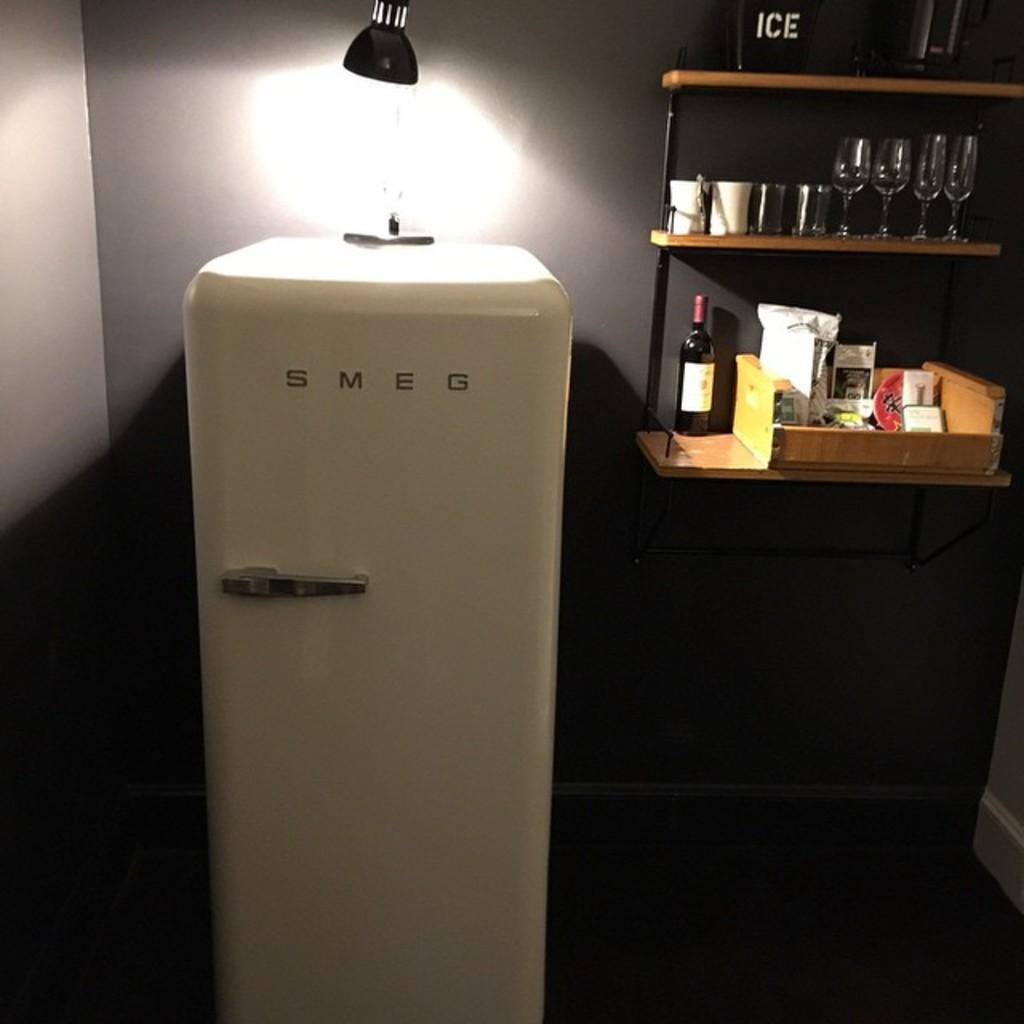<image>
Offer a succinct explanation of the picture presented. A small SMEG refrigerator sits next to a small bar with glasses 